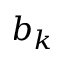<formula> <loc_0><loc_0><loc_500><loc_500>b _ { k }</formula> 